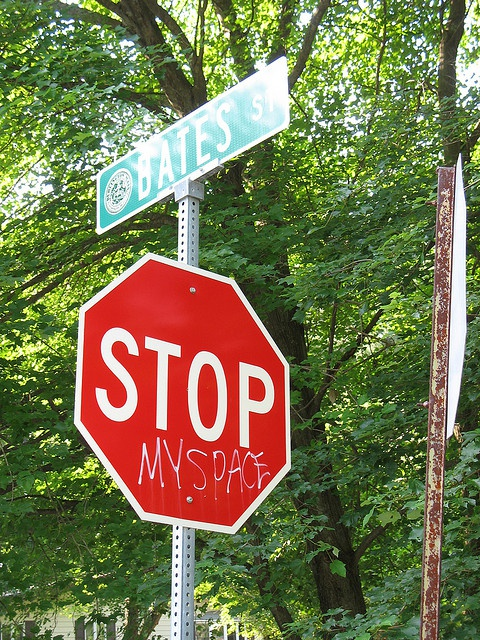Describe the objects in this image and their specific colors. I can see a stop sign in darkgreen, red, white, brown, and lightpink tones in this image. 